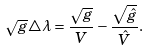Convert formula to latex. <formula><loc_0><loc_0><loc_500><loc_500>\sqrt { g } \triangle \lambda = \frac { \sqrt { g } } { V } - \frac { \sqrt { \hat { g } } } { \hat { V } } .</formula> 